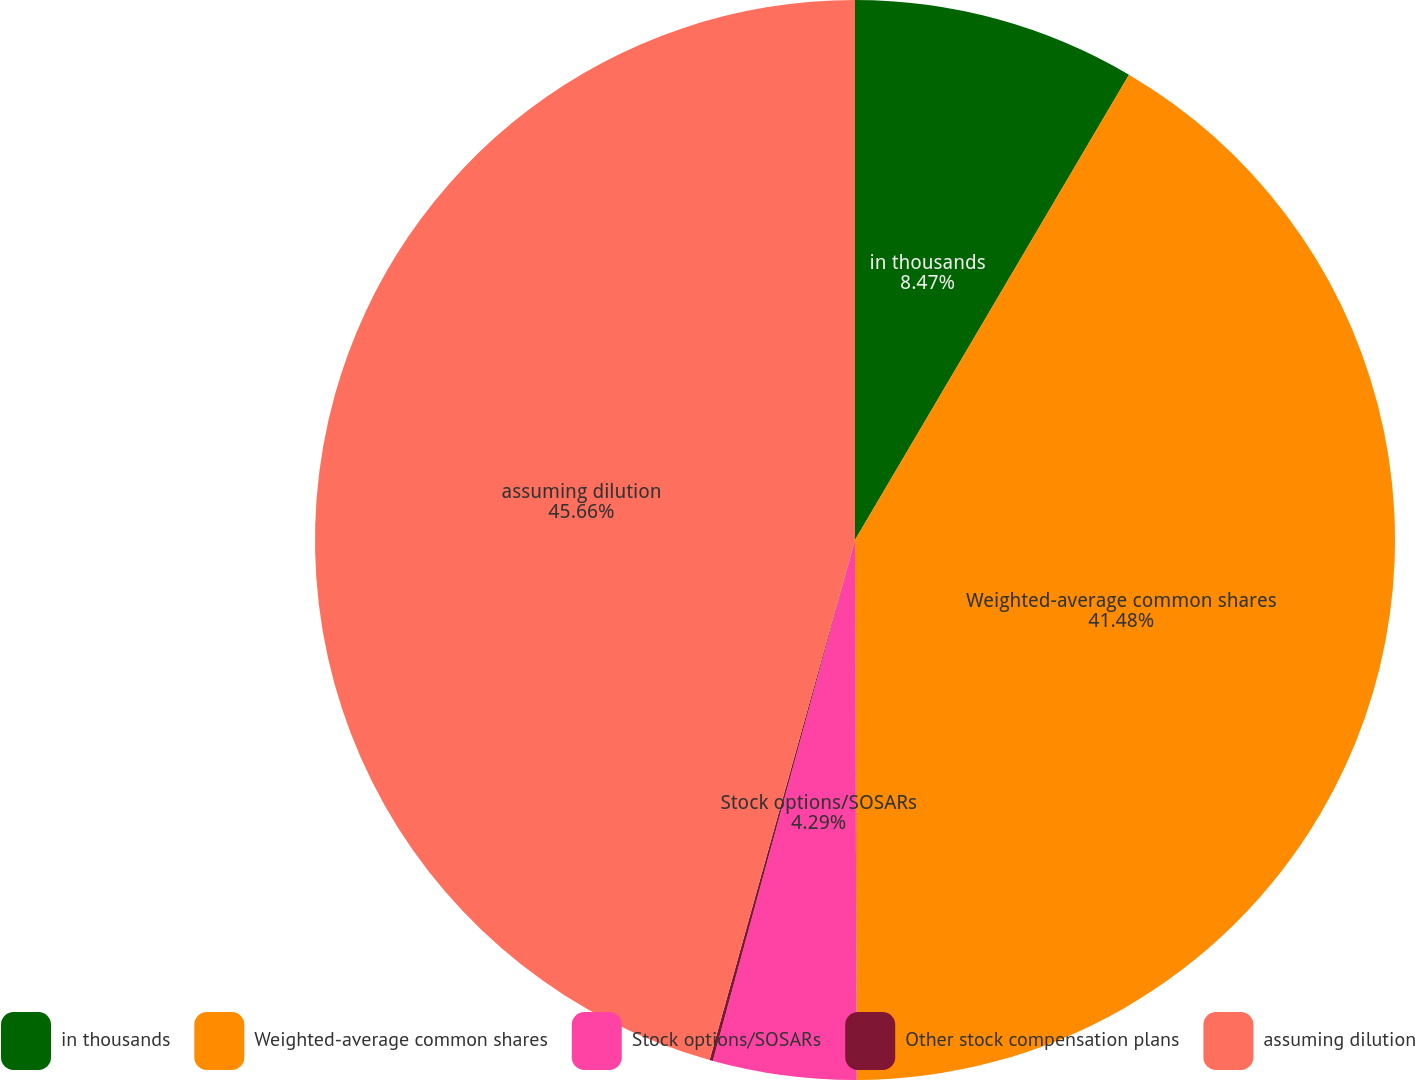<chart> <loc_0><loc_0><loc_500><loc_500><pie_chart><fcel>in thousands<fcel>Weighted-average common shares<fcel>Stock options/SOSARs<fcel>Other stock compensation plans<fcel>assuming dilution<nl><fcel>8.47%<fcel>41.48%<fcel>4.29%<fcel>0.1%<fcel>45.66%<nl></chart> 